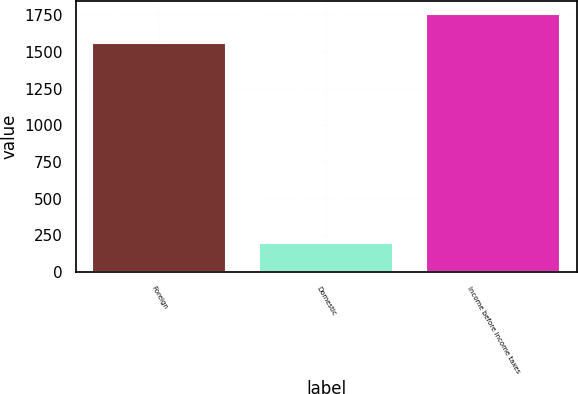Convert chart to OTSL. <chart><loc_0><loc_0><loc_500><loc_500><bar_chart><fcel>Foreign<fcel>Domestic<fcel>Income before income taxes<nl><fcel>1559<fcel>198<fcel>1757<nl></chart> 